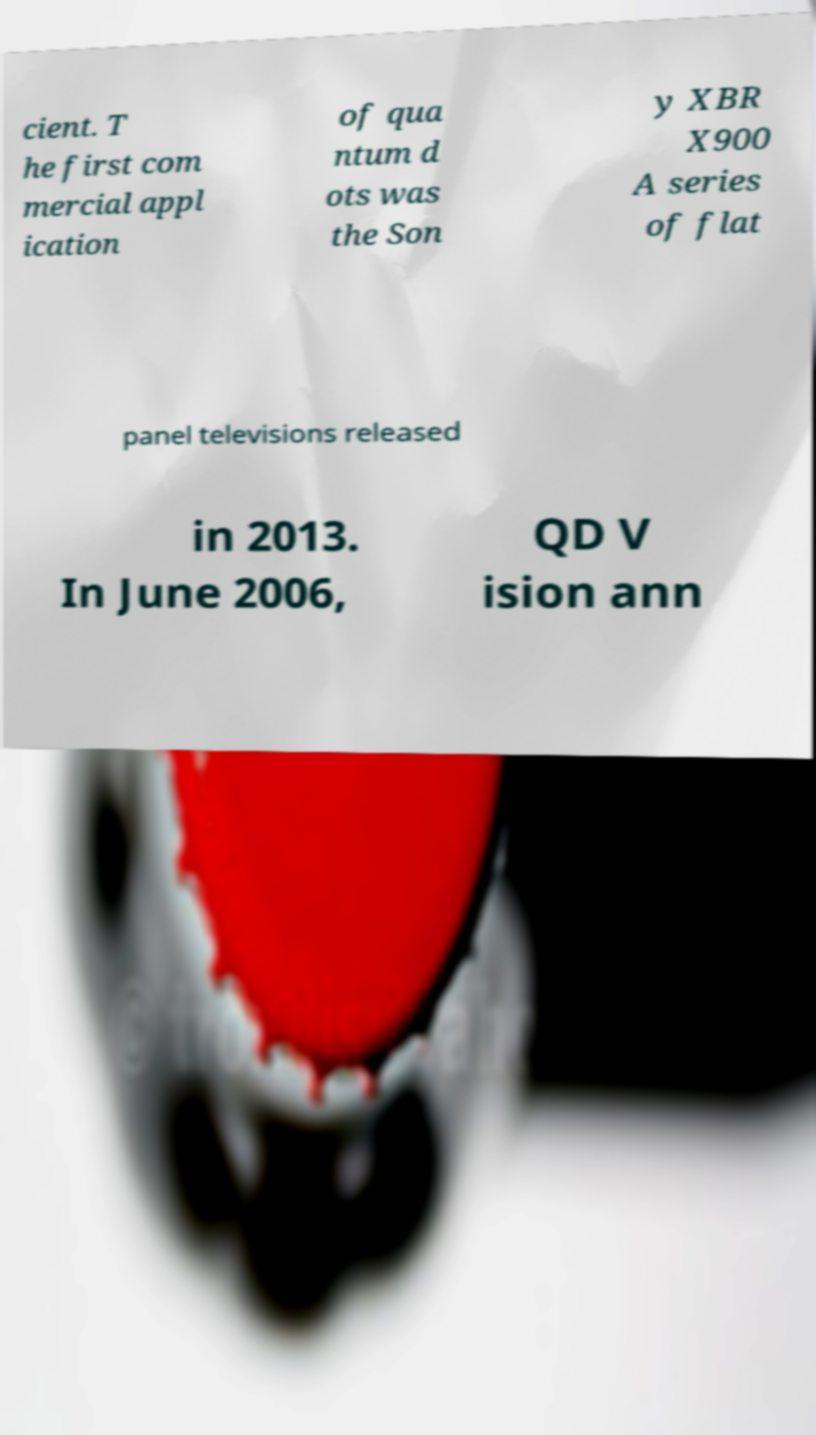I need the written content from this picture converted into text. Can you do that? cient. T he first com mercial appl ication of qua ntum d ots was the Son y XBR X900 A series of flat panel televisions released in 2013. In June 2006, QD V ision ann 